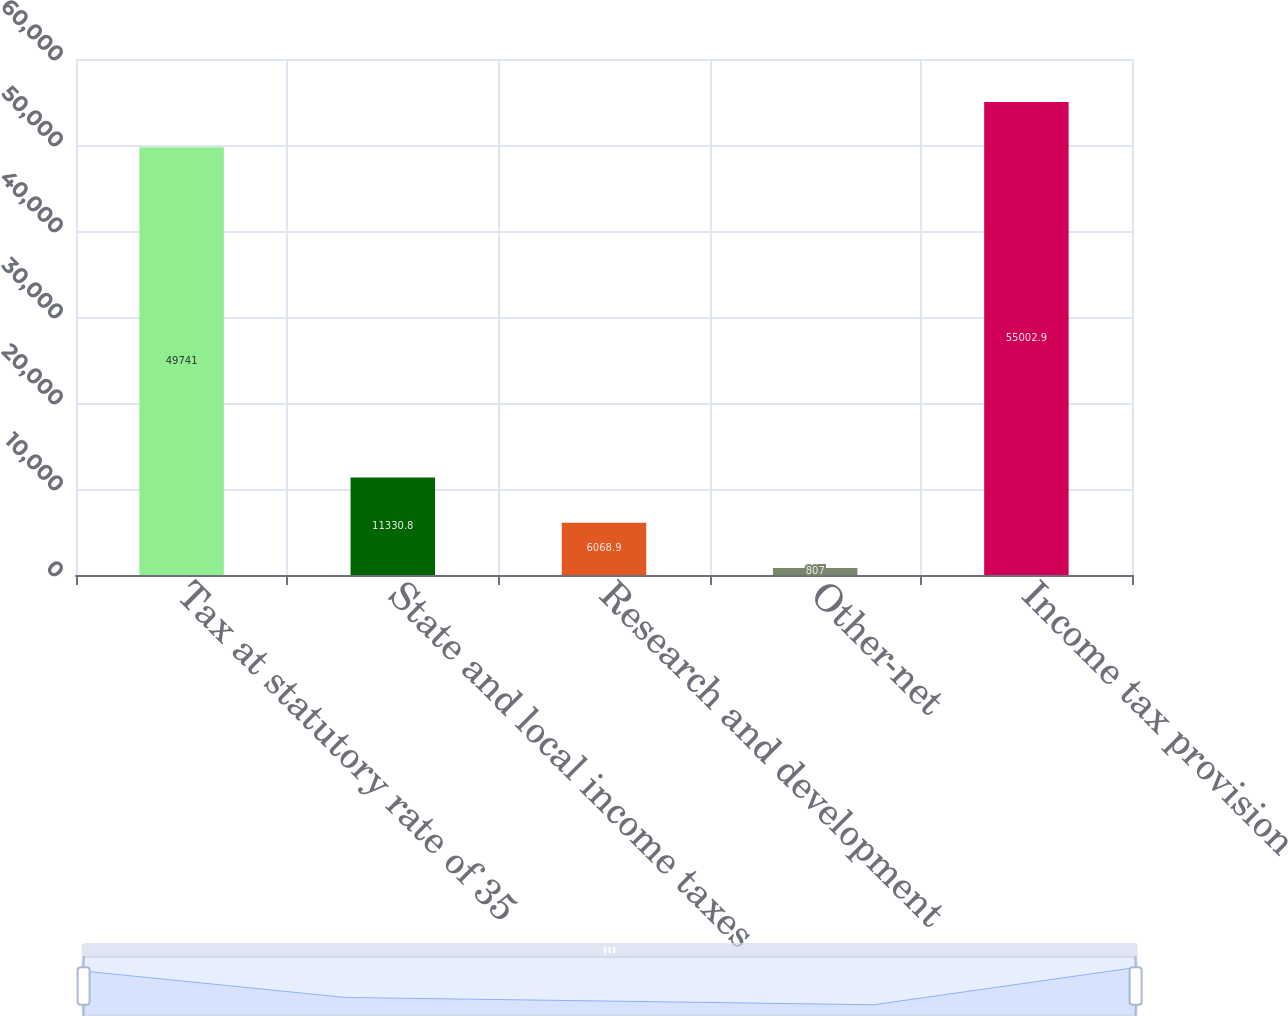<chart> <loc_0><loc_0><loc_500><loc_500><bar_chart><fcel>Tax at statutory rate of 35<fcel>State and local income taxes<fcel>Research and development<fcel>Other-net<fcel>Income tax provision<nl><fcel>49741<fcel>11330.8<fcel>6068.9<fcel>807<fcel>55002.9<nl></chart> 